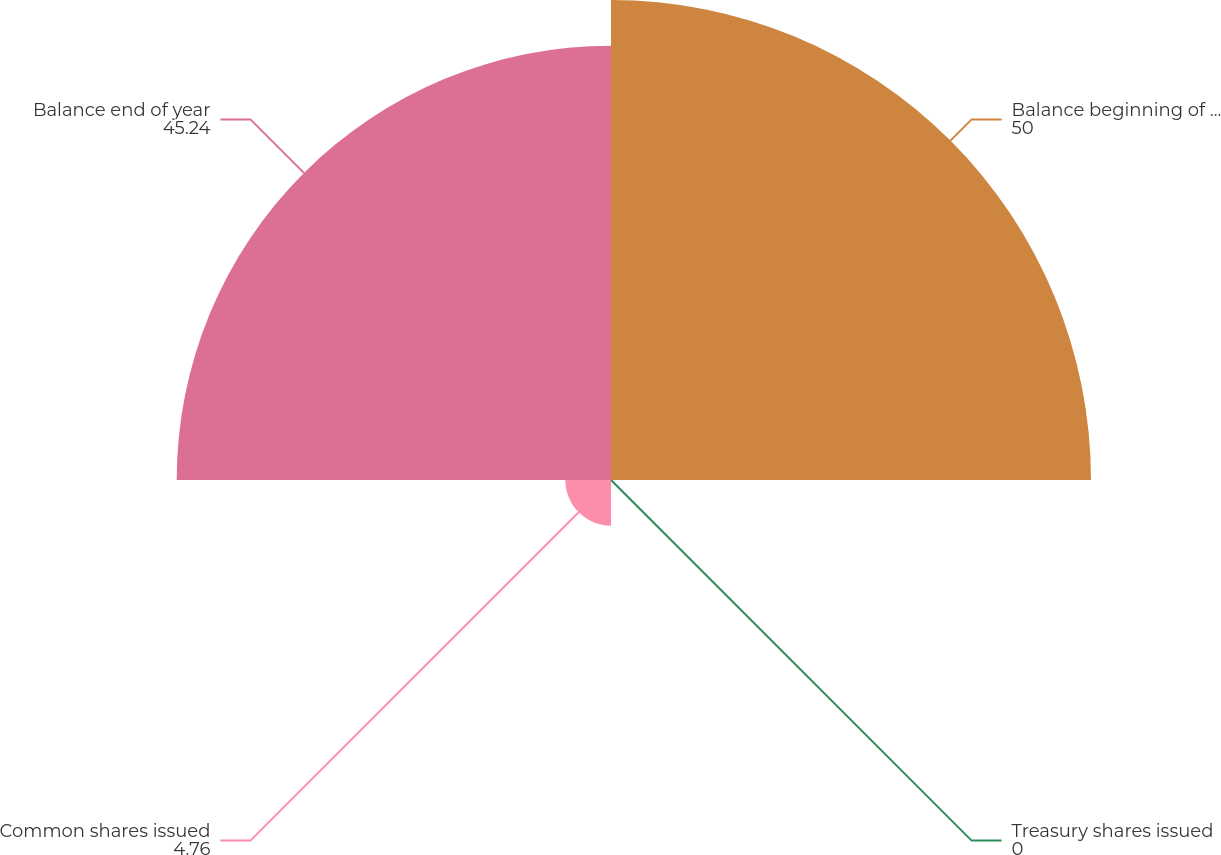<chart> <loc_0><loc_0><loc_500><loc_500><pie_chart><fcel>Balance beginning of year<fcel>Treasury shares issued<fcel>Common shares issued<fcel>Balance end of year<nl><fcel>50.0%<fcel>0.0%<fcel>4.76%<fcel>45.24%<nl></chart> 